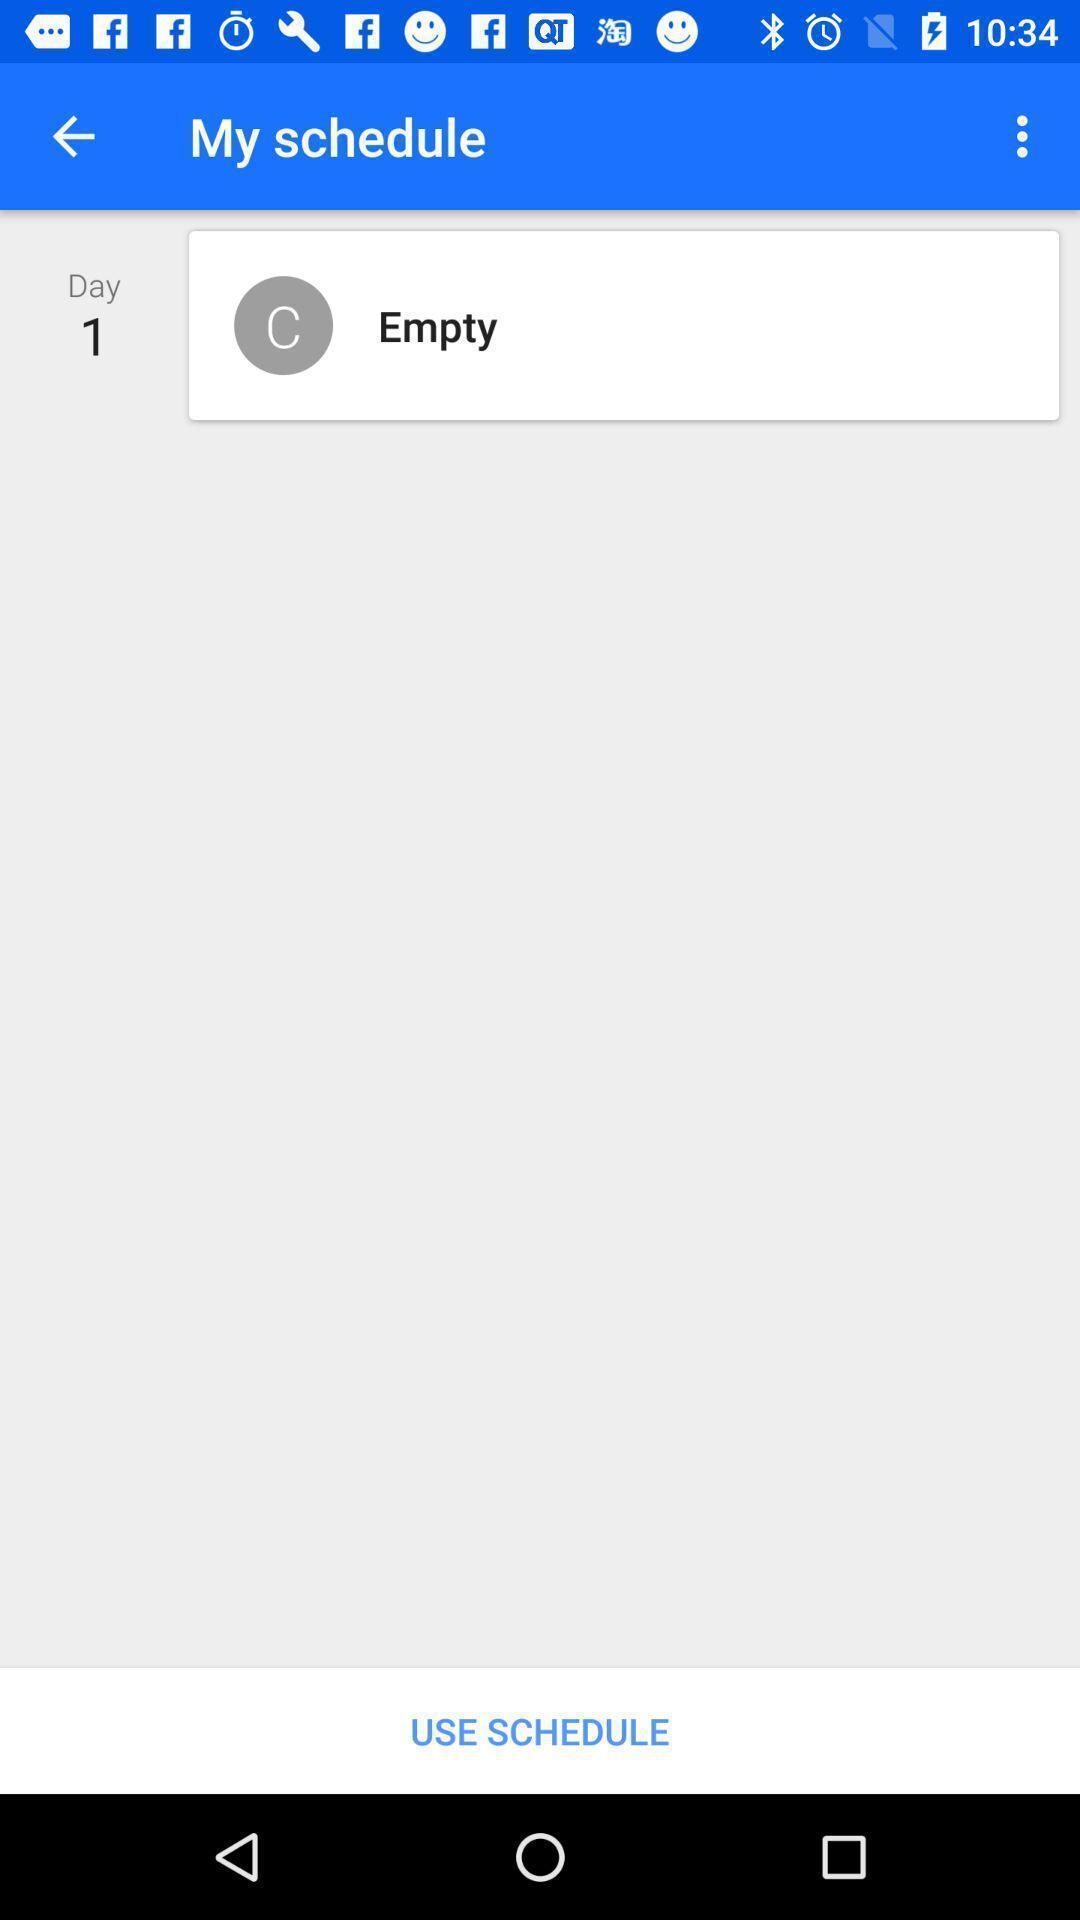Explain what's happening in this screen capture. Screen shows an empty page of schedules. 